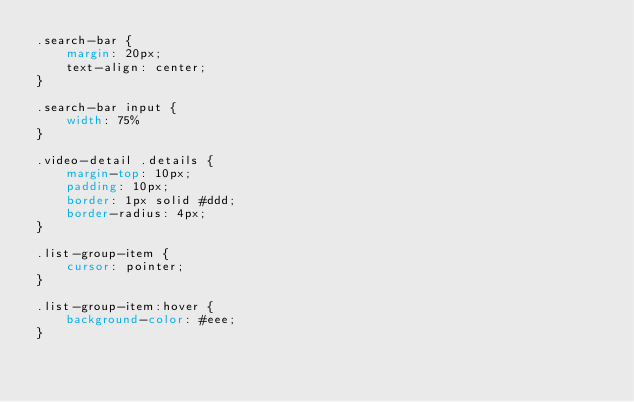Convert code to text. <code><loc_0><loc_0><loc_500><loc_500><_CSS_>.search-bar {
    margin: 20px;
    text-align: center;
}

.search-bar input {
    width: 75%
}

.video-detail .details {
    margin-top: 10px;
    padding: 10px;
    border: 1px solid #ddd;
    border-radius: 4px;
}

.list-group-item {
    cursor: pointer;
}

.list-group-item:hover {
    background-color: #eee;
}</code> 